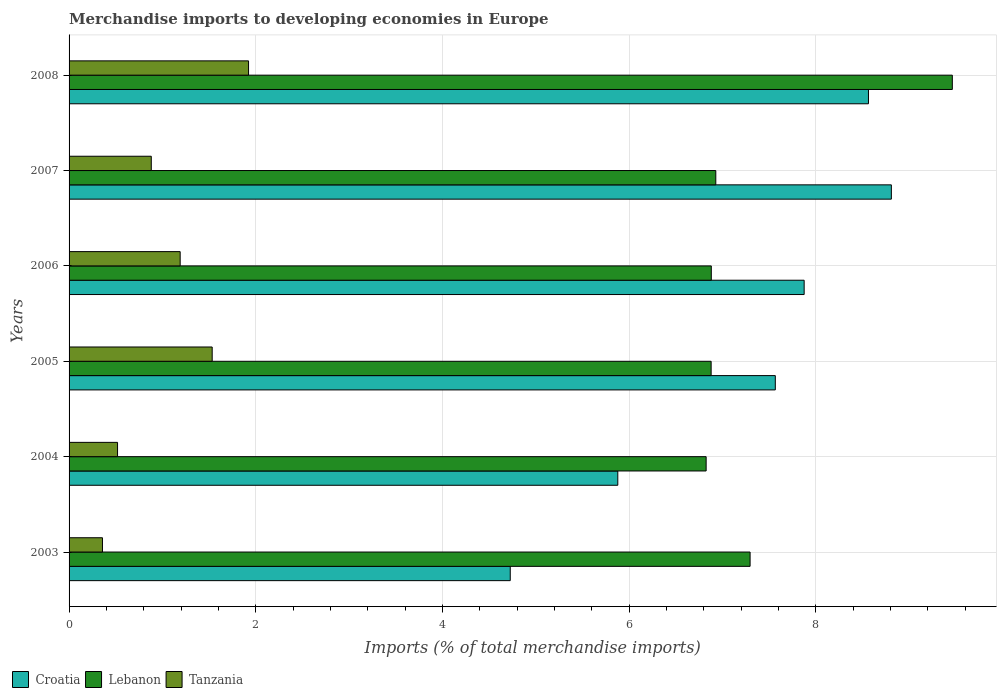How many groups of bars are there?
Offer a very short reply. 6. How many bars are there on the 4th tick from the bottom?
Provide a short and direct response. 3. In how many cases, is the number of bars for a given year not equal to the number of legend labels?
Provide a short and direct response. 0. What is the percentage total merchandise imports in Tanzania in 2005?
Make the answer very short. 1.53. Across all years, what is the maximum percentage total merchandise imports in Croatia?
Your response must be concise. 8.81. Across all years, what is the minimum percentage total merchandise imports in Lebanon?
Give a very brief answer. 6.82. In which year was the percentage total merchandise imports in Tanzania maximum?
Offer a terse response. 2008. In which year was the percentage total merchandise imports in Croatia minimum?
Offer a terse response. 2003. What is the total percentage total merchandise imports in Tanzania in the graph?
Your response must be concise. 6.4. What is the difference between the percentage total merchandise imports in Croatia in 2006 and that in 2008?
Your response must be concise. -0.69. What is the difference between the percentage total merchandise imports in Lebanon in 2005 and the percentage total merchandise imports in Croatia in 2008?
Offer a very short reply. -1.69. What is the average percentage total merchandise imports in Tanzania per year?
Offer a very short reply. 1.07. In the year 2003, what is the difference between the percentage total merchandise imports in Croatia and percentage total merchandise imports in Lebanon?
Offer a very short reply. -2.57. In how many years, is the percentage total merchandise imports in Tanzania greater than 2.8 %?
Offer a very short reply. 0. What is the ratio of the percentage total merchandise imports in Lebanon in 2004 to that in 2006?
Your answer should be compact. 0.99. Is the difference between the percentage total merchandise imports in Croatia in 2003 and 2007 greater than the difference between the percentage total merchandise imports in Lebanon in 2003 and 2007?
Make the answer very short. No. What is the difference between the highest and the second highest percentage total merchandise imports in Croatia?
Ensure brevity in your answer.  0.25. What is the difference between the highest and the lowest percentage total merchandise imports in Croatia?
Offer a terse response. 4.08. Is the sum of the percentage total merchandise imports in Lebanon in 2006 and 2008 greater than the maximum percentage total merchandise imports in Croatia across all years?
Keep it short and to the point. Yes. What does the 2nd bar from the top in 2005 represents?
Ensure brevity in your answer.  Lebanon. What does the 3rd bar from the bottom in 2008 represents?
Provide a succinct answer. Tanzania. How many bars are there?
Your response must be concise. 18. What is the difference between two consecutive major ticks on the X-axis?
Give a very brief answer. 2. Where does the legend appear in the graph?
Provide a short and direct response. Bottom left. How many legend labels are there?
Offer a terse response. 3. How are the legend labels stacked?
Your answer should be very brief. Horizontal. What is the title of the graph?
Provide a succinct answer. Merchandise imports to developing economies in Europe. What is the label or title of the X-axis?
Offer a terse response. Imports (% of total merchandise imports). What is the label or title of the Y-axis?
Ensure brevity in your answer.  Years. What is the Imports (% of total merchandise imports) of Croatia in 2003?
Your answer should be compact. 4.73. What is the Imports (% of total merchandise imports) in Lebanon in 2003?
Your answer should be very brief. 7.3. What is the Imports (% of total merchandise imports) of Tanzania in 2003?
Your answer should be very brief. 0.36. What is the Imports (% of total merchandise imports) in Croatia in 2004?
Ensure brevity in your answer.  5.88. What is the Imports (% of total merchandise imports) in Lebanon in 2004?
Your response must be concise. 6.82. What is the Imports (% of total merchandise imports) of Tanzania in 2004?
Make the answer very short. 0.52. What is the Imports (% of total merchandise imports) of Croatia in 2005?
Offer a terse response. 7.57. What is the Imports (% of total merchandise imports) of Lebanon in 2005?
Give a very brief answer. 6.88. What is the Imports (% of total merchandise imports) of Tanzania in 2005?
Provide a short and direct response. 1.53. What is the Imports (% of total merchandise imports) in Croatia in 2006?
Make the answer very short. 7.87. What is the Imports (% of total merchandise imports) of Lebanon in 2006?
Offer a terse response. 6.88. What is the Imports (% of total merchandise imports) of Tanzania in 2006?
Keep it short and to the point. 1.19. What is the Imports (% of total merchandise imports) of Croatia in 2007?
Your answer should be very brief. 8.81. What is the Imports (% of total merchandise imports) in Lebanon in 2007?
Offer a terse response. 6.93. What is the Imports (% of total merchandise imports) in Tanzania in 2007?
Give a very brief answer. 0.88. What is the Imports (% of total merchandise imports) in Croatia in 2008?
Provide a short and direct response. 8.56. What is the Imports (% of total merchandise imports) in Lebanon in 2008?
Provide a succinct answer. 9.46. What is the Imports (% of total merchandise imports) of Tanzania in 2008?
Your answer should be very brief. 1.92. Across all years, what is the maximum Imports (% of total merchandise imports) of Croatia?
Offer a terse response. 8.81. Across all years, what is the maximum Imports (% of total merchandise imports) in Lebanon?
Offer a terse response. 9.46. Across all years, what is the maximum Imports (% of total merchandise imports) in Tanzania?
Keep it short and to the point. 1.92. Across all years, what is the minimum Imports (% of total merchandise imports) in Croatia?
Provide a succinct answer. 4.73. Across all years, what is the minimum Imports (% of total merchandise imports) in Lebanon?
Provide a short and direct response. 6.82. Across all years, what is the minimum Imports (% of total merchandise imports) of Tanzania?
Provide a short and direct response. 0.36. What is the total Imports (% of total merchandise imports) of Croatia in the graph?
Keep it short and to the point. 43.41. What is the total Imports (% of total merchandise imports) of Lebanon in the graph?
Provide a short and direct response. 44.27. What is the total Imports (% of total merchandise imports) of Tanzania in the graph?
Ensure brevity in your answer.  6.4. What is the difference between the Imports (% of total merchandise imports) in Croatia in 2003 and that in 2004?
Offer a terse response. -1.15. What is the difference between the Imports (% of total merchandise imports) in Lebanon in 2003 and that in 2004?
Give a very brief answer. 0.47. What is the difference between the Imports (% of total merchandise imports) of Tanzania in 2003 and that in 2004?
Give a very brief answer. -0.16. What is the difference between the Imports (% of total merchandise imports) in Croatia in 2003 and that in 2005?
Your response must be concise. -2.84. What is the difference between the Imports (% of total merchandise imports) in Lebanon in 2003 and that in 2005?
Make the answer very short. 0.42. What is the difference between the Imports (% of total merchandise imports) in Tanzania in 2003 and that in 2005?
Make the answer very short. -1.18. What is the difference between the Imports (% of total merchandise imports) of Croatia in 2003 and that in 2006?
Your response must be concise. -3.15. What is the difference between the Imports (% of total merchandise imports) in Lebanon in 2003 and that in 2006?
Your answer should be very brief. 0.42. What is the difference between the Imports (% of total merchandise imports) in Tanzania in 2003 and that in 2006?
Your answer should be very brief. -0.83. What is the difference between the Imports (% of total merchandise imports) in Croatia in 2003 and that in 2007?
Give a very brief answer. -4.08. What is the difference between the Imports (% of total merchandise imports) of Lebanon in 2003 and that in 2007?
Offer a very short reply. 0.37. What is the difference between the Imports (% of total merchandise imports) in Tanzania in 2003 and that in 2007?
Your answer should be very brief. -0.52. What is the difference between the Imports (% of total merchandise imports) in Croatia in 2003 and that in 2008?
Your answer should be compact. -3.84. What is the difference between the Imports (% of total merchandise imports) of Lebanon in 2003 and that in 2008?
Keep it short and to the point. -2.17. What is the difference between the Imports (% of total merchandise imports) in Tanzania in 2003 and that in 2008?
Give a very brief answer. -1.56. What is the difference between the Imports (% of total merchandise imports) in Croatia in 2004 and that in 2005?
Give a very brief answer. -1.69. What is the difference between the Imports (% of total merchandise imports) of Lebanon in 2004 and that in 2005?
Make the answer very short. -0.05. What is the difference between the Imports (% of total merchandise imports) of Tanzania in 2004 and that in 2005?
Make the answer very short. -1.01. What is the difference between the Imports (% of total merchandise imports) of Croatia in 2004 and that in 2006?
Give a very brief answer. -2. What is the difference between the Imports (% of total merchandise imports) in Lebanon in 2004 and that in 2006?
Your answer should be very brief. -0.06. What is the difference between the Imports (% of total merchandise imports) of Tanzania in 2004 and that in 2006?
Make the answer very short. -0.67. What is the difference between the Imports (% of total merchandise imports) of Croatia in 2004 and that in 2007?
Offer a terse response. -2.93. What is the difference between the Imports (% of total merchandise imports) of Lebanon in 2004 and that in 2007?
Provide a short and direct response. -0.1. What is the difference between the Imports (% of total merchandise imports) of Tanzania in 2004 and that in 2007?
Provide a short and direct response. -0.36. What is the difference between the Imports (% of total merchandise imports) of Croatia in 2004 and that in 2008?
Ensure brevity in your answer.  -2.69. What is the difference between the Imports (% of total merchandise imports) of Lebanon in 2004 and that in 2008?
Keep it short and to the point. -2.64. What is the difference between the Imports (% of total merchandise imports) of Tanzania in 2004 and that in 2008?
Your answer should be very brief. -1.4. What is the difference between the Imports (% of total merchandise imports) in Croatia in 2005 and that in 2006?
Your response must be concise. -0.31. What is the difference between the Imports (% of total merchandise imports) of Lebanon in 2005 and that in 2006?
Give a very brief answer. -0. What is the difference between the Imports (% of total merchandise imports) in Tanzania in 2005 and that in 2006?
Keep it short and to the point. 0.34. What is the difference between the Imports (% of total merchandise imports) in Croatia in 2005 and that in 2007?
Make the answer very short. -1.24. What is the difference between the Imports (% of total merchandise imports) in Lebanon in 2005 and that in 2007?
Offer a terse response. -0.05. What is the difference between the Imports (% of total merchandise imports) in Tanzania in 2005 and that in 2007?
Your answer should be very brief. 0.65. What is the difference between the Imports (% of total merchandise imports) in Croatia in 2005 and that in 2008?
Offer a very short reply. -1. What is the difference between the Imports (% of total merchandise imports) of Lebanon in 2005 and that in 2008?
Offer a very short reply. -2.58. What is the difference between the Imports (% of total merchandise imports) in Tanzania in 2005 and that in 2008?
Offer a terse response. -0.39. What is the difference between the Imports (% of total merchandise imports) of Croatia in 2006 and that in 2007?
Make the answer very short. -0.93. What is the difference between the Imports (% of total merchandise imports) in Lebanon in 2006 and that in 2007?
Your answer should be very brief. -0.05. What is the difference between the Imports (% of total merchandise imports) of Tanzania in 2006 and that in 2007?
Offer a terse response. 0.31. What is the difference between the Imports (% of total merchandise imports) of Croatia in 2006 and that in 2008?
Offer a terse response. -0.69. What is the difference between the Imports (% of total merchandise imports) in Lebanon in 2006 and that in 2008?
Provide a succinct answer. -2.58. What is the difference between the Imports (% of total merchandise imports) in Tanzania in 2006 and that in 2008?
Your answer should be compact. -0.73. What is the difference between the Imports (% of total merchandise imports) in Croatia in 2007 and that in 2008?
Ensure brevity in your answer.  0.25. What is the difference between the Imports (% of total merchandise imports) in Lebanon in 2007 and that in 2008?
Your answer should be compact. -2.53. What is the difference between the Imports (% of total merchandise imports) in Tanzania in 2007 and that in 2008?
Your answer should be very brief. -1.04. What is the difference between the Imports (% of total merchandise imports) of Croatia in 2003 and the Imports (% of total merchandise imports) of Lebanon in 2004?
Your answer should be compact. -2.1. What is the difference between the Imports (% of total merchandise imports) in Croatia in 2003 and the Imports (% of total merchandise imports) in Tanzania in 2004?
Provide a succinct answer. 4.21. What is the difference between the Imports (% of total merchandise imports) of Lebanon in 2003 and the Imports (% of total merchandise imports) of Tanzania in 2004?
Keep it short and to the point. 6.78. What is the difference between the Imports (% of total merchandise imports) in Croatia in 2003 and the Imports (% of total merchandise imports) in Lebanon in 2005?
Ensure brevity in your answer.  -2.15. What is the difference between the Imports (% of total merchandise imports) in Croatia in 2003 and the Imports (% of total merchandise imports) in Tanzania in 2005?
Give a very brief answer. 3.19. What is the difference between the Imports (% of total merchandise imports) of Lebanon in 2003 and the Imports (% of total merchandise imports) of Tanzania in 2005?
Make the answer very short. 5.76. What is the difference between the Imports (% of total merchandise imports) in Croatia in 2003 and the Imports (% of total merchandise imports) in Lebanon in 2006?
Offer a very short reply. -2.15. What is the difference between the Imports (% of total merchandise imports) of Croatia in 2003 and the Imports (% of total merchandise imports) of Tanzania in 2006?
Your response must be concise. 3.54. What is the difference between the Imports (% of total merchandise imports) of Lebanon in 2003 and the Imports (% of total merchandise imports) of Tanzania in 2006?
Your answer should be compact. 6.11. What is the difference between the Imports (% of total merchandise imports) in Croatia in 2003 and the Imports (% of total merchandise imports) in Lebanon in 2007?
Make the answer very short. -2.2. What is the difference between the Imports (% of total merchandise imports) in Croatia in 2003 and the Imports (% of total merchandise imports) in Tanzania in 2007?
Your answer should be compact. 3.85. What is the difference between the Imports (% of total merchandise imports) in Lebanon in 2003 and the Imports (% of total merchandise imports) in Tanzania in 2007?
Offer a terse response. 6.41. What is the difference between the Imports (% of total merchandise imports) of Croatia in 2003 and the Imports (% of total merchandise imports) of Lebanon in 2008?
Make the answer very short. -4.74. What is the difference between the Imports (% of total merchandise imports) of Croatia in 2003 and the Imports (% of total merchandise imports) of Tanzania in 2008?
Your response must be concise. 2.8. What is the difference between the Imports (% of total merchandise imports) of Lebanon in 2003 and the Imports (% of total merchandise imports) of Tanzania in 2008?
Keep it short and to the point. 5.37. What is the difference between the Imports (% of total merchandise imports) in Croatia in 2004 and the Imports (% of total merchandise imports) in Lebanon in 2005?
Your response must be concise. -1. What is the difference between the Imports (% of total merchandise imports) of Croatia in 2004 and the Imports (% of total merchandise imports) of Tanzania in 2005?
Keep it short and to the point. 4.34. What is the difference between the Imports (% of total merchandise imports) of Lebanon in 2004 and the Imports (% of total merchandise imports) of Tanzania in 2005?
Your answer should be compact. 5.29. What is the difference between the Imports (% of total merchandise imports) in Croatia in 2004 and the Imports (% of total merchandise imports) in Lebanon in 2006?
Offer a very short reply. -1. What is the difference between the Imports (% of total merchandise imports) in Croatia in 2004 and the Imports (% of total merchandise imports) in Tanzania in 2006?
Ensure brevity in your answer.  4.69. What is the difference between the Imports (% of total merchandise imports) in Lebanon in 2004 and the Imports (% of total merchandise imports) in Tanzania in 2006?
Your response must be concise. 5.63. What is the difference between the Imports (% of total merchandise imports) in Croatia in 2004 and the Imports (% of total merchandise imports) in Lebanon in 2007?
Keep it short and to the point. -1.05. What is the difference between the Imports (% of total merchandise imports) in Croatia in 2004 and the Imports (% of total merchandise imports) in Tanzania in 2007?
Ensure brevity in your answer.  5. What is the difference between the Imports (% of total merchandise imports) of Lebanon in 2004 and the Imports (% of total merchandise imports) of Tanzania in 2007?
Offer a terse response. 5.94. What is the difference between the Imports (% of total merchandise imports) in Croatia in 2004 and the Imports (% of total merchandise imports) in Lebanon in 2008?
Keep it short and to the point. -3.58. What is the difference between the Imports (% of total merchandise imports) of Croatia in 2004 and the Imports (% of total merchandise imports) of Tanzania in 2008?
Offer a very short reply. 3.96. What is the difference between the Imports (% of total merchandise imports) in Lebanon in 2004 and the Imports (% of total merchandise imports) in Tanzania in 2008?
Keep it short and to the point. 4.9. What is the difference between the Imports (% of total merchandise imports) in Croatia in 2005 and the Imports (% of total merchandise imports) in Lebanon in 2006?
Make the answer very short. 0.69. What is the difference between the Imports (% of total merchandise imports) in Croatia in 2005 and the Imports (% of total merchandise imports) in Tanzania in 2006?
Offer a very short reply. 6.38. What is the difference between the Imports (% of total merchandise imports) of Lebanon in 2005 and the Imports (% of total merchandise imports) of Tanzania in 2006?
Provide a short and direct response. 5.69. What is the difference between the Imports (% of total merchandise imports) in Croatia in 2005 and the Imports (% of total merchandise imports) in Lebanon in 2007?
Provide a succinct answer. 0.64. What is the difference between the Imports (% of total merchandise imports) in Croatia in 2005 and the Imports (% of total merchandise imports) in Tanzania in 2007?
Offer a terse response. 6.68. What is the difference between the Imports (% of total merchandise imports) in Lebanon in 2005 and the Imports (% of total merchandise imports) in Tanzania in 2007?
Keep it short and to the point. 6. What is the difference between the Imports (% of total merchandise imports) of Croatia in 2005 and the Imports (% of total merchandise imports) of Lebanon in 2008?
Your answer should be very brief. -1.9. What is the difference between the Imports (% of total merchandise imports) of Croatia in 2005 and the Imports (% of total merchandise imports) of Tanzania in 2008?
Provide a short and direct response. 5.64. What is the difference between the Imports (% of total merchandise imports) of Lebanon in 2005 and the Imports (% of total merchandise imports) of Tanzania in 2008?
Offer a terse response. 4.96. What is the difference between the Imports (% of total merchandise imports) in Croatia in 2006 and the Imports (% of total merchandise imports) in Lebanon in 2007?
Keep it short and to the point. 0.95. What is the difference between the Imports (% of total merchandise imports) in Croatia in 2006 and the Imports (% of total merchandise imports) in Tanzania in 2007?
Keep it short and to the point. 6.99. What is the difference between the Imports (% of total merchandise imports) in Lebanon in 2006 and the Imports (% of total merchandise imports) in Tanzania in 2007?
Your response must be concise. 6. What is the difference between the Imports (% of total merchandise imports) of Croatia in 2006 and the Imports (% of total merchandise imports) of Lebanon in 2008?
Provide a short and direct response. -1.59. What is the difference between the Imports (% of total merchandise imports) of Croatia in 2006 and the Imports (% of total merchandise imports) of Tanzania in 2008?
Make the answer very short. 5.95. What is the difference between the Imports (% of total merchandise imports) of Lebanon in 2006 and the Imports (% of total merchandise imports) of Tanzania in 2008?
Give a very brief answer. 4.96. What is the difference between the Imports (% of total merchandise imports) in Croatia in 2007 and the Imports (% of total merchandise imports) in Lebanon in 2008?
Offer a terse response. -0.65. What is the difference between the Imports (% of total merchandise imports) of Croatia in 2007 and the Imports (% of total merchandise imports) of Tanzania in 2008?
Offer a very short reply. 6.89. What is the difference between the Imports (% of total merchandise imports) in Lebanon in 2007 and the Imports (% of total merchandise imports) in Tanzania in 2008?
Provide a succinct answer. 5.01. What is the average Imports (% of total merchandise imports) of Croatia per year?
Offer a very short reply. 7.24. What is the average Imports (% of total merchandise imports) in Lebanon per year?
Your response must be concise. 7.38. What is the average Imports (% of total merchandise imports) of Tanzania per year?
Keep it short and to the point. 1.07. In the year 2003, what is the difference between the Imports (% of total merchandise imports) of Croatia and Imports (% of total merchandise imports) of Lebanon?
Your answer should be compact. -2.57. In the year 2003, what is the difference between the Imports (% of total merchandise imports) in Croatia and Imports (% of total merchandise imports) in Tanzania?
Your response must be concise. 4.37. In the year 2003, what is the difference between the Imports (% of total merchandise imports) in Lebanon and Imports (% of total merchandise imports) in Tanzania?
Provide a succinct answer. 6.94. In the year 2004, what is the difference between the Imports (% of total merchandise imports) of Croatia and Imports (% of total merchandise imports) of Lebanon?
Keep it short and to the point. -0.95. In the year 2004, what is the difference between the Imports (% of total merchandise imports) of Croatia and Imports (% of total merchandise imports) of Tanzania?
Keep it short and to the point. 5.36. In the year 2004, what is the difference between the Imports (% of total merchandise imports) in Lebanon and Imports (% of total merchandise imports) in Tanzania?
Provide a short and direct response. 6.3. In the year 2005, what is the difference between the Imports (% of total merchandise imports) of Croatia and Imports (% of total merchandise imports) of Lebanon?
Keep it short and to the point. 0.69. In the year 2005, what is the difference between the Imports (% of total merchandise imports) in Croatia and Imports (% of total merchandise imports) in Tanzania?
Keep it short and to the point. 6.03. In the year 2005, what is the difference between the Imports (% of total merchandise imports) in Lebanon and Imports (% of total merchandise imports) in Tanzania?
Your answer should be compact. 5.34. In the year 2006, what is the difference between the Imports (% of total merchandise imports) of Croatia and Imports (% of total merchandise imports) of Lebanon?
Keep it short and to the point. 0.99. In the year 2006, what is the difference between the Imports (% of total merchandise imports) in Croatia and Imports (% of total merchandise imports) in Tanzania?
Offer a terse response. 6.68. In the year 2006, what is the difference between the Imports (% of total merchandise imports) in Lebanon and Imports (% of total merchandise imports) in Tanzania?
Provide a short and direct response. 5.69. In the year 2007, what is the difference between the Imports (% of total merchandise imports) in Croatia and Imports (% of total merchandise imports) in Lebanon?
Provide a succinct answer. 1.88. In the year 2007, what is the difference between the Imports (% of total merchandise imports) in Croatia and Imports (% of total merchandise imports) in Tanzania?
Your answer should be very brief. 7.93. In the year 2007, what is the difference between the Imports (% of total merchandise imports) of Lebanon and Imports (% of total merchandise imports) of Tanzania?
Your answer should be very brief. 6.05. In the year 2008, what is the difference between the Imports (% of total merchandise imports) of Croatia and Imports (% of total merchandise imports) of Lebanon?
Your answer should be compact. -0.9. In the year 2008, what is the difference between the Imports (% of total merchandise imports) of Croatia and Imports (% of total merchandise imports) of Tanzania?
Keep it short and to the point. 6.64. In the year 2008, what is the difference between the Imports (% of total merchandise imports) in Lebanon and Imports (% of total merchandise imports) in Tanzania?
Make the answer very short. 7.54. What is the ratio of the Imports (% of total merchandise imports) of Croatia in 2003 to that in 2004?
Keep it short and to the point. 0.8. What is the ratio of the Imports (% of total merchandise imports) of Lebanon in 2003 to that in 2004?
Give a very brief answer. 1.07. What is the ratio of the Imports (% of total merchandise imports) in Tanzania in 2003 to that in 2004?
Provide a short and direct response. 0.69. What is the ratio of the Imports (% of total merchandise imports) of Croatia in 2003 to that in 2005?
Your answer should be compact. 0.62. What is the ratio of the Imports (% of total merchandise imports) of Lebanon in 2003 to that in 2005?
Your response must be concise. 1.06. What is the ratio of the Imports (% of total merchandise imports) in Tanzania in 2003 to that in 2005?
Keep it short and to the point. 0.23. What is the ratio of the Imports (% of total merchandise imports) of Croatia in 2003 to that in 2006?
Make the answer very short. 0.6. What is the ratio of the Imports (% of total merchandise imports) of Lebanon in 2003 to that in 2006?
Your response must be concise. 1.06. What is the ratio of the Imports (% of total merchandise imports) in Tanzania in 2003 to that in 2006?
Offer a terse response. 0.3. What is the ratio of the Imports (% of total merchandise imports) of Croatia in 2003 to that in 2007?
Keep it short and to the point. 0.54. What is the ratio of the Imports (% of total merchandise imports) in Lebanon in 2003 to that in 2007?
Give a very brief answer. 1.05. What is the ratio of the Imports (% of total merchandise imports) of Tanzania in 2003 to that in 2007?
Your answer should be compact. 0.41. What is the ratio of the Imports (% of total merchandise imports) of Croatia in 2003 to that in 2008?
Offer a very short reply. 0.55. What is the ratio of the Imports (% of total merchandise imports) in Lebanon in 2003 to that in 2008?
Make the answer very short. 0.77. What is the ratio of the Imports (% of total merchandise imports) of Tanzania in 2003 to that in 2008?
Your answer should be compact. 0.19. What is the ratio of the Imports (% of total merchandise imports) in Croatia in 2004 to that in 2005?
Your response must be concise. 0.78. What is the ratio of the Imports (% of total merchandise imports) in Lebanon in 2004 to that in 2005?
Keep it short and to the point. 0.99. What is the ratio of the Imports (% of total merchandise imports) of Tanzania in 2004 to that in 2005?
Provide a short and direct response. 0.34. What is the ratio of the Imports (% of total merchandise imports) in Croatia in 2004 to that in 2006?
Your answer should be very brief. 0.75. What is the ratio of the Imports (% of total merchandise imports) in Tanzania in 2004 to that in 2006?
Keep it short and to the point. 0.44. What is the ratio of the Imports (% of total merchandise imports) of Croatia in 2004 to that in 2007?
Ensure brevity in your answer.  0.67. What is the ratio of the Imports (% of total merchandise imports) of Lebanon in 2004 to that in 2007?
Your response must be concise. 0.99. What is the ratio of the Imports (% of total merchandise imports) of Tanzania in 2004 to that in 2007?
Your answer should be very brief. 0.59. What is the ratio of the Imports (% of total merchandise imports) in Croatia in 2004 to that in 2008?
Provide a succinct answer. 0.69. What is the ratio of the Imports (% of total merchandise imports) of Lebanon in 2004 to that in 2008?
Your response must be concise. 0.72. What is the ratio of the Imports (% of total merchandise imports) in Tanzania in 2004 to that in 2008?
Your response must be concise. 0.27. What is the ratio of the Imports (% of total merchandise imports) in Croatia in 2005 to that in 2006?
Your answer should be compact. 0.96. What is the ratio of the Imports (% of total merchandise imports) in Lebanon in 2005 to that in 2006?
Offer a very short reply. 1. What is the ratio of the Imports (% of total merchandise imports) in Tanzania in 2005 to that in 2006?
Provide a short and direct response. 1.29. What is the ratio of the Imports (% of total merchandise imports) of Croatia in 2005 to that in 2007?
Your answer should be compact. 0.86. What is the ratio of the Imports (% of total merchandise imports) of Tanzania in 2005 to that in 2007?
Offer a terse response. 1.74. What is the ratio of the Imports (% of total merchandise imports) in Croatia in 2005 to that in 2008?
Offer a terse response. 0.88. What is the ratio of the Imports (% of total merchandise imports) in Lebanon in 2005 to that in 2008?
Keep it short and to the point. 0.73. What is the ratio of the Imports (% of total merchandise imports) in Tanzania in 2005 to that in 2008?
Give a very brief answer. 0.8. What is the ratio of the Imports (% of total merchandise imports) of Croatia in 2006 to that in 2007?
Make the answer very short. 0.89. What is the ratio of the Imports (% of total merchandise imports) of Tanzania in 2006 to that in 2007?
Offer a very short reply. 1.35. What is the ratio of the Imports (% of total merchandise imports) in Croatia in 2006 to that in 2008?
Offer a very short reply. 0.92. What is the ratio of the Imports (% of total merchandise imports) in Lebanon in 2006 to that in 2008?
Offer a very short reply. 0.73. What is the ratio of the Imports (% of total merchandise imports) in Tanzania in 2006 to that in 2008?
Offer a terse response. 0.62. What is the ratio of the Imports (% of total merchandise imports) of Croatia in 2007 to that in 2008?
Provide a short and direct response. 1.03. What is the ratio of the Imports (% of total merchandise imports) in Lebanon in 2007 to that in 2008?
Keep it short and to the point. 0.73. What is the ratio of the Imports (% of total merchandise imports) of Tanzania in 2007 to that in 2008?
Provide a short and direct response. 0.46. What is the difference between the highest and the second highest Imports (% of total merchandise imports) of Croatia?
Provide a short and direct response. 0.25. What is the difference between the highest and the second highest Imports (% of total merchandise imports) in Lebanon?
Provide a succinct answer. 2.17. What is the difference between the highest and the second highest Imports (% of total merchandise imports) of Tanzania?
Give a very brief answer. 0.39. What is the difference between the highest and the lowest Imports (% of total merchandise imports) in Croatia?
Offer a very short reply. 4.08. What is the difference between the highest and the lowest Imports (% of total merchandise imports) in Lebanon?
Your answer should be compact. 2.64. What is the difference between the highest and the lowest Imports (% of total merchandise imports) in Tanzania?
Provide a short and direct response. 1.56. 